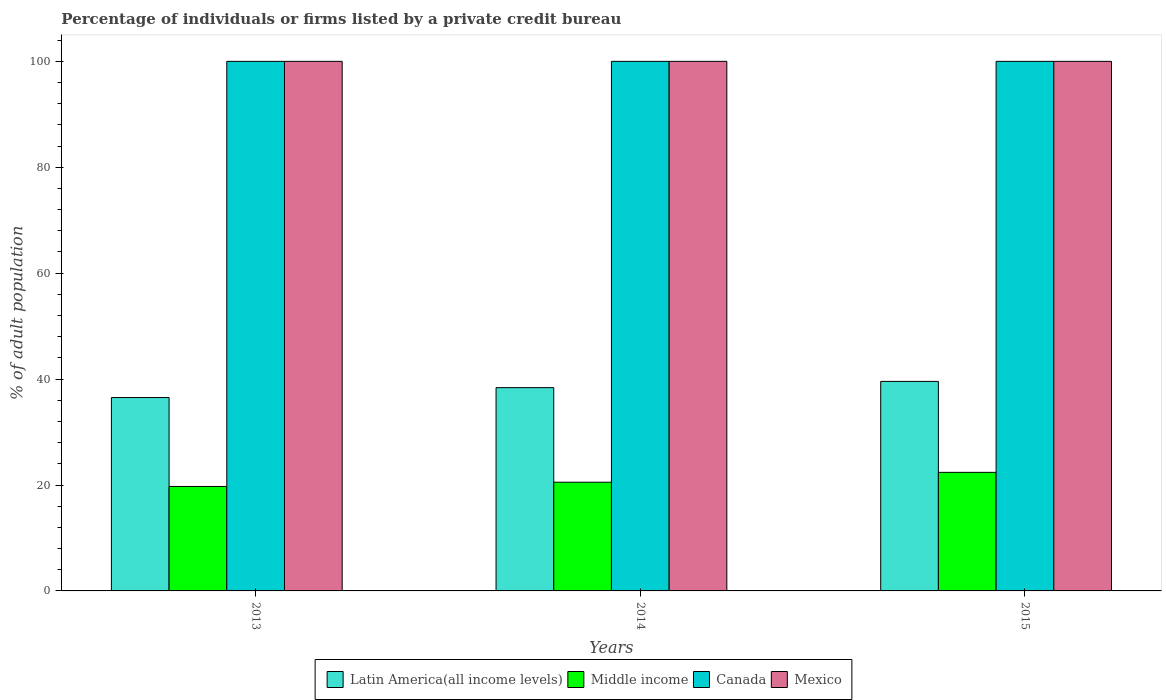How many different coloured bars are there?
Provide a short and direct response. 4. How many groups of bars are there?
Ensure brevity in your answer.  3. Are the number of bars on each tick of the X-axis equal?
Give a very brief answer. Yes. What is the label of the 3rd group of bars from the left?
Offer a very short reply. 2015. What is the percentage of population listed by a private credit bureau in Canada in 2015?
Ensure brevity in your answer.  100. Across all years, what is the maximum percentage of population listed by a private credit bureau in Middle income?
Make the answer very short. 22.39. Across all years, what is the minimum percentage of population listed by a private credit bureau in Middle income?
Provide a succinct answer. 19.73. In which year was the percentage of population listed by a private credit bureau in Canada maximum?
Your response must be concise. 2013. In which year was the percentage of population listed by a private credit bureau in Latin America(all income levels) minimum?
Provide a short and direct response. 2013. What is the total percentage of population listed by a private credit bureau in Mexico in the graph?
Your response must be concise. 300. What is the difference between the percentage of population listed by a private credit bureau in Middle income in 2013 and that in 2015?
Provide a short and direct response. -2.66. What is the difference between the percentage of population listed by a private credit bureau in Canada in 2015 and the percentage of population listed by a private credit bureau in Middle income in 2013?
Ensure brevity in your answer.  80.27. What is the average percentage of population listed by a private credit bureau in Canada per year?
Ensure brevity in your answer.  100. In the year 2013, what is the difference between the percentage of population listed by a private credit bureau in Canada and percentage of population listed by a private credit bureau in Latin America(all income levels)?
Provide a succinct answer. 63.48. In how many years, is the percentage of population listed by a private credit bureau in Canada greater than 44 %?
Your answer should be very brief. 3. What is the ratio of the percentage of population listed by a private credit bureau in Canada in 2013 to that in 2015?
Make the answer very short. 1. Is the difference between the percentage of population listed by a private credit bureau in Canada in 2013 and 2014 greater than the difference between the percentage of population listed by a private credit bureau in Latin America(all income levels) in 2013 and 2014?
Make the answer very short. Yes. What is the difference between the highest and the lowest percentage of population listed by a private credit bureau in Canada?
Your response must be concise. 0. Is it the case that in every year, the sum of the percentage of population listed by a private credit bureau in Latin America(all income levels) and percentage of population listed by a private credit bureau in Canada is greater than the sum of percentage of population listed by a private credit bureau in Middle income and percentage of population listed by a private credit bureau in Mexico?
Provide a short and direct response. Yes. Are all the bars in the graph horizontal?
Your response must be concise. No. How many years are there in the graph?
Offer a very short reply. 3. What is the difference between two consecutive major ticks on the Y-axis?
Offer a very short reply. 20. Are the values on the major ticks of Y-axis written in scientific E-notation?
Ensure brevity in your answer.  No. Does the graph contain any zero values?
Give a very brief answer. No. Does the graph contain grids?
Keep it short and to the point. No. How many legend labels are there?
Provide a succinct answer. 4. How are the legend labels stacked?
Your answer should be very brief. Horizontal. What is the title of the graph?
Provide a succinct answer. Percentage of individuals or firms listed by a private credit bureau. Does "Ecuador" appear as one of the legend labels in the graph?
Offer a very short reply. No. What is the label or title of the X-axis?
Your answer should be very brief. Years. What is the label or title of the Y-axis?
Offer a terse response. % of adult population. What is the % of adult population in Latin America(all income levels) in 2013?
Your answer should be very brief. 36.52. What is the % of adult population in Middle income in 2013?
Make the answer very short. 19.73. What is the % of adult population in Canada in 2013?
Offer a terse response. 100. What is the % of adult population of Mexico in 2013?
Your answer should be compact. 100. What is the % of adult population in Latin America(all income levels) in 2014?
Keep it short and to the point. 38.38. What is the % of adult population in Middle income in 2014?
Offer a terse response. 20.53. What is the % of adult population of Latin America(all income levels) in 2015?
Provide a succinct answer. 39.56. What is the % of adult population of Middle income in 2015?
Your answer should be very brief. 22.39. What is the % of adult population of Canada in 2015?
Offer a very short reply. 100. What is the % of adult population of Mexico in 2015?
Your answer should be compact. 100. Across all years, what is the maximum % of adult population of Latin America(all income levels)?
Give a very brief answer. 39.56. Across all years, what is the maximum % of adult population in Middle income?
Ensure brevity in your answer.  22.39. Across all years, what is the minimum % of adult population of Latin America(all income levels)?
Give a very brief answer. 36.52. Across all years, what is the minimum % of adult population of Middle income?
Keep it short and to the point. 19.73. Across all years, what is the minimum % of adult population in Mexico?
Provide a short and direct response. 100. What is the total % of adult population of Latin America(all income levels) in the graph?
Your answer should be compact. 114.47. What is the total % of adult population in Middle income in the graph?
Provide a short and direct response. 62.65. What is the total % of adult population in Canada in the graph?
Provide a short and direct response. 300. What is the total % of adult population in Mexico in the graph?
Keep it short and to the point. 300. What is the difference between the % of adult population in Latin America(all income levels) in 2013 and that in 2014?
Provide a succinct answer. -1.87. What is the difference between the % of adult population of Middle income in 2013 and that in 2014?
Your answer should be very brief. -0.8. What is the difference between the % of adult population of Mexico in 2013 and that in 2014?
Provide a short and direct response. 0. What is the difference between the % of adult population in Latin America(all income levels) in 2013 and that in 2015?
Your response must be concise. -3.05. What is the difference between the % of adult population in Middle income in 2013 and that in 2015?
Offer a terse response. -2.66. What is the difference between the % of adult population in Mexico in 2013 and that in 2015?
Give a very brief answer. 0. What is the difference between the % of adult population in Latin America(all income levels) in 2014 and that in 2015?
Your response must be concise. -1.18. What is the difference between the % of adult population in Middle income in 2014 and that in 2015?
Your answer should be compact. -1.86. What is the difference between the % of adult population of Canada in 2014 and that in 2015?
Provide a short and direct response. 0. What is the difference between the % of adult population of Mexico in 2014 and that in 2015?
Ensure brevity in your answer.  0. What is the difference between the % of adult population of Latin America(all income levels) in 2013 and the % of adult population of Middle income in 2014?
Offer a very short reply. 15.99. What is the difference between the % of adult population of Latin America(all income levels) in 2013 and the % of adult population of Canada in 2014?
Offer a terse response. -63.48. What is the difference between the % of adult population in Latin America(all income levels) in 2013 and the % of adult population in Mexico in 2014?
Give a very brief answer. -63.48. What is the difference between the % of adult population in Middle income in 2013 and the % of adult population in Canada in 2014?
Provide a short and direct response. -80.27. What is the difference between the % of adult population in Middle income in 2013 and the % of adult population in Mexico in 2014?
Your answer should be compact. -80.27. What is the difference between the % of adult population of Latin America(all income levels) in 2013 and the % of adult population of Middle income in 2015?
Ensure brevity in your answer.  14.13. What is the difference between the % of adult population of Latin America(all income levels) in 2013 and the % of adult population of Canada in 2015?
Your response must be concise. -63.48. What is the difference between the % of adult population of Latin America(all income levels) in 2013 and the % of adult population of Mexico in 2015?
Your response must be concise. -63.48. What is the difference between the % of adult population in Middle income in 2013 and the % of adult population in Canada in 2015?
Keep it short and to the point. -80.27. What is the difference between the % of adult population in Middle income in 2013 and the % of adult population in Mexico in 2015?
Offer a terse response. -80.27. What is the difference between the % of adult population in Latin America(all income levels) in 2014 and the % of adult population in Middle income in 2015?
Your answer should be very brief. 15.99. What is the difference between the % of adult population of Latin America(all income levels) in 2014 and the % of adult population of Canada in 2015?
Your answer should be compact. -61.62. What is the difference between the % of adult population of Latin America(all income levels) in 2014 and the % of adult population of Mexico in 2015?
Offer a very short reply. -61.62. What is the difference between the % of adult population in Middle income in 2014 and the % of adult population in Canada in 2015?
Ensure brevity in your answer.  -79.47. What is the difference between the % of adult population of Middle income in 2014 and the % of adult population of Mexico in 2015?
Make the answer very short. -79.47. What is the average % of adult population in Latin America(all income levels) per year?
Give a very brief answer. 38.16. What is the average % of adult population of Middle income per year?
Your response must be concise. 20.88. What is the average % of adult population in Canada per year?
Offer a very short reply. 100. What is the average % of adult population in Mexico per year?
Offer a terse response. 100. In the year 2013, what is the difference between the % of adult population of Latin America(all income levels) and % of adult population of Middle income?
Your answer should be compact. 16.79. In the year 2013, what is the difference between the % of adult population of Latin America(all income levels) and % of adult population of Canada?
Offer a very short reply. -63.48. In the year 2013, what is the difference between the % of adult population in Latin America(all income levels) and % of adult population in Mexico?
Provide a succinct answer. -63.48. In the year 2013, what is the difference between the % of adult population in Middle income and % of adult population in Canada?
Keep it short and to the point. -80.27. In the year 2013, what is the difference between the % of adult population in Middle income and % of adult population in Mexico?
Your response must be concise. -80.27. In the year 2013, what is the difference between the % of adult population in Canada and % of adult population in Mexico?
Offer a very short reply. 0. In the year 2014, what is the difference between the % of adult population in Latin America(all income levels) and % of adult population in Middle income?
Ensure brevity in your answer.  17.86. In the year 2014, what is the difference between the % of adult population in Latin America(all income levels) and % of adult population in Canada?
Your answer should be compact. -61.62. In the year 2014, what is the difference between the % of adult population in Latin America(all income levels) and % of adult population in Mexico?
Your response must be concise. -61.62. In the year 2014, what is the difference between the % of adult population of Middle income and % of adult population of Canada?
Keep it short and to the point. -79.47. In the year 2014, what is the difference between the % of adult population of Middle income and % of adult population of Mexico?
Make the answer very short. -79.47. In the year 2015, what is the difference between the % of adult population in Latin America(all income levels) and % of adult population in Middle income?
Offer a very short reply. 17.17. In the year 2015, what is the difference between the % of adult population of Latin America(all income levels) and % of adult population of Canada?
Your response must be concise. -60.44. In the year 2015, what is the difference between the % of adult population of Latin America(all income levels) and % of adult population of Mexico?
Your answer should be very brief. -60.44. In the year 2015, what is the difference between the % of adult population of Middle income and % of adult population of Canada?
Give a very brief answer. -77.61. In the year 2015, what is the difference between the % of adult population in Middle income and % of adult population in Mexico?
Keep it short and to the point. -77.61. In the year 2015, what is the difference between the % of adult population of Canada and % of adult population of Mexico?
Offer a very short reply. 0. What is the ratio of the % of adult population in Latin America(all income levels) in 2013 to that in 2014?
Offer a terse response. 0.95. What is the ratio of the % of adult population of Middle income in 2013 to that in 2014?
Give a very brief answer. 0.96. What is the ratio of the % of adult population of Canada in 2013 to that in 2014?
Make the answer very short. 1. What is the ratio of the % of adult population in Mexico in 2013 to that in 2014?
Give a very brief answer. 1. What is the ratio of the % of adult population in Latin America(all income levels) in 2013 to that in 2015?
Give a very brief answer. 0.92. What is the ratio of the % of adult population in Middle income in 2013 to that in 2015?
Ensure brevity in your answer.  0.88. What is the ratio of the % of adult population of Latin America(all income levels) in 2014 to that in 2015?
Make the answer very short. 0.97. What is the ratio of the % of adult population of Middle income in 2014 to that in 2015?
Provide a succinct answer. 0.92. What is the ratio of the % of adult population in Canada in 2014 to that in 2015?
Your answer should be compact. 1. What is the ratio of the % of adult population of Mexico in 2014 to that in 2015?
Offer a very short reply. 1. What is the difference between the highest and the second highest % of adult population of Latin America(all income levels)?
Offer a very short reply. 1.18. What is the difference between the highest and the second highest % of adult population in Middle income?
Keep it short and to the point. 1.86. What is the difference between the highest and the second highest % of adult population in Mexico?
Offer a very short reply. 0. What is the difference between the highest and the lowest % of adult population of Latin America(all income levels)?
Offer a very short reply. 3.05. What is the difference between the highest and the lowest % of adult population in Middle income?
Provide a short and direct response. 2.66. 